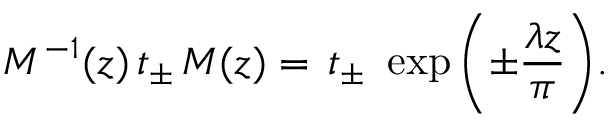<formula> <loc_0><loc_0><loc_500><loc_500>M ^ { - 1 } ( z ) \, t _ { \pm } \, M ( z ) = \, t _ { \pm } \, \exp { \left ( \pm \frac { \lambda z } { \pi } \right ) } .</formula> 